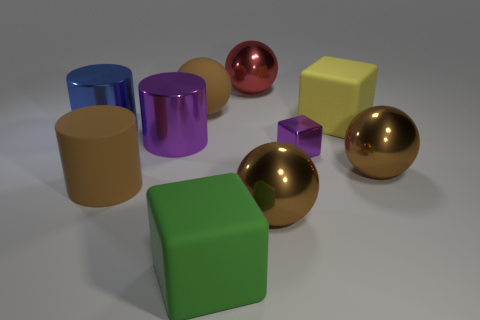Are there any large rubber cylinders of the same color as the tiny shiny object?
Offer a terse response. No. There is a purple metal thing to the right of the red metallic object; is it the same size as the purple metal object that is on the left side of the red metal ball?
Your response must be concise. No. Is the number of big yellow blocks that are left of the green block greater than the number of purple metallic objects to the right of the yellow thing?
Offer a terse response. No. Are there any large purple cylinders made of the same material as the large yellow cube?
Your answer should be compact. No. Is the color of the small metal cube the same as the matte cylinder?
Ensure brevity in your answer.  No. What is the material of the big brown object that is behind the big rubber cylinder and in front of the small thing?
Your answer should be very brief. Metal. The metal cube has what color?
Your answer should be compact. Purple. What number of other rubber things have the same shape as the small thing?
Your answer should be very brief. 2. Is the big cube behind the brown rubber cylinder made of the same material as the big block in front of the big blue object?
Ensure brevity in your answer.  Yes. There is a purple metal object to the left of the large rubber object that is behind the big yellow cube; what size is it?
Your answer should be very brief. Large. 